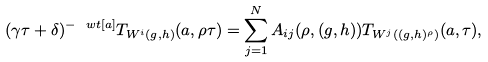<formula> <loc_0><loc_0><loc_500><loc_500>( \gamma \tau + \delta ) ^ { - \ w t [ a ] } T _ { W ^ { i } ( g , h ) } ( a , \rho \tau ) = \sum _ { j = 1 } ^ { N } A _ { i j } ( \rho , ( g , h ) ) T _ { W ^ { j } ( ( g , h ) ^ { \rho } ) } ( a , \tau ) ,</formula> 